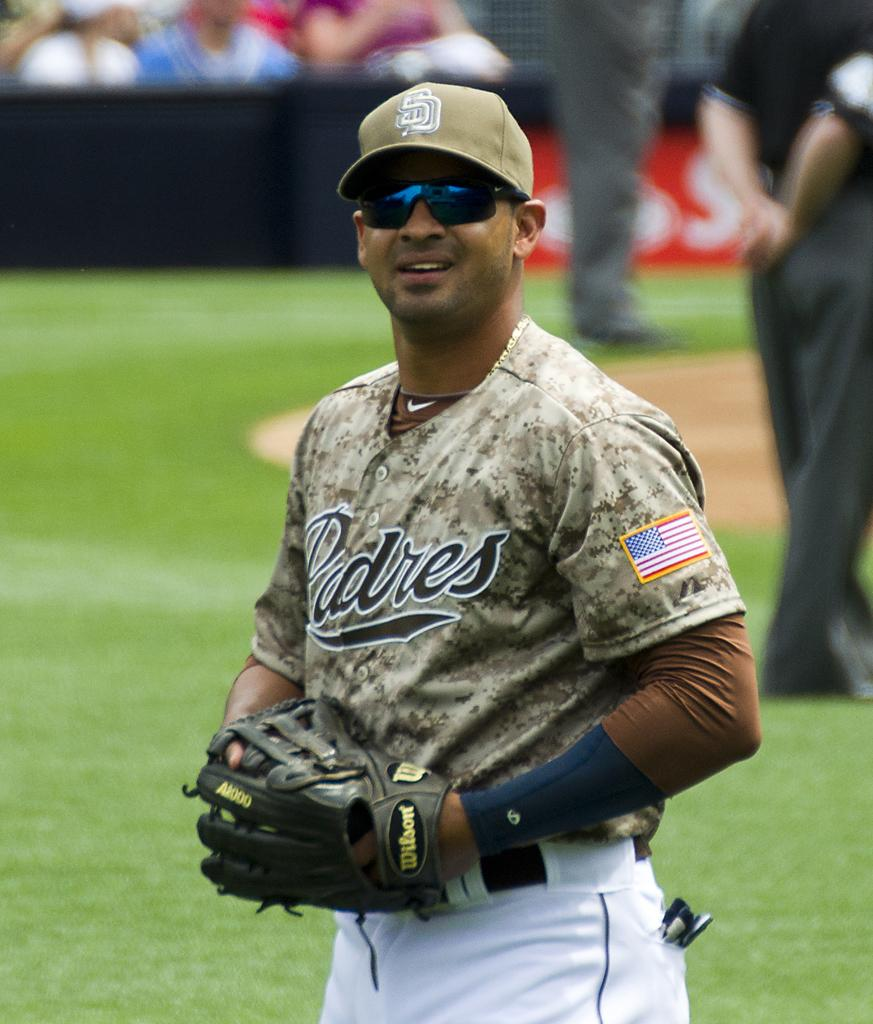<image>
Offer a succinct explanation of the picture presented. A Padres baseball player with sunglasses holding his glove. 